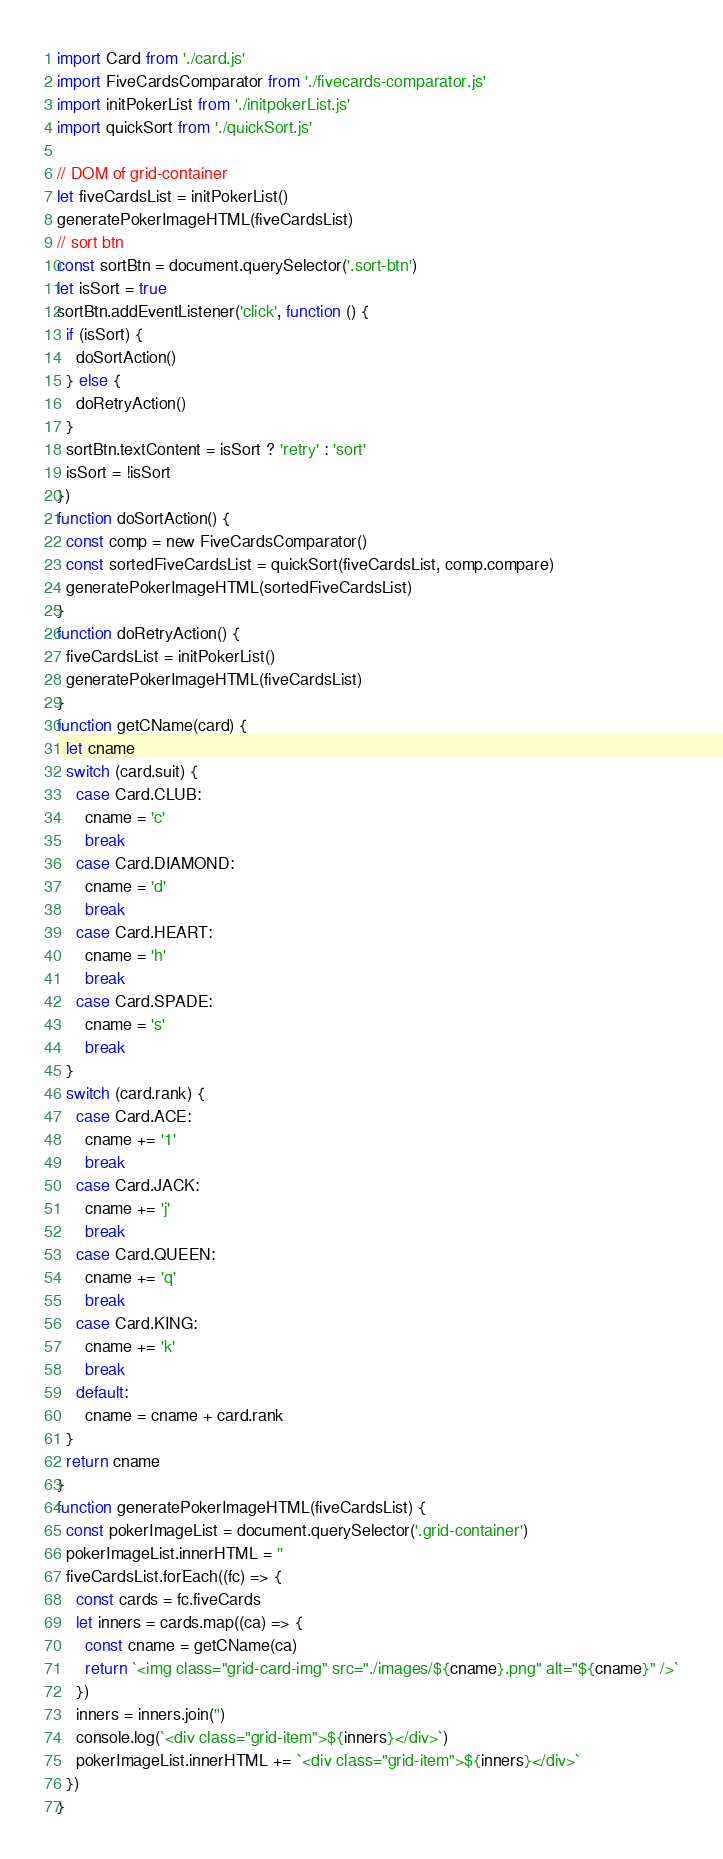Convert code to text. <code><loc_0><loc_0><loc_500><loc_500><_JavaScript_>import Card from './card.js'
import FiveCardsComparator from './fivecards-comparator.js'
import initPokerList from './initpokerList.js'
import quickSort from './quickSort.js'

// DOM of grid-container
let fiveCardsList = initPokerList()
generatePokerImageHTML(fiveCardsList)
// sort btn
const sortBtn = document.querySelector('.sort-btn')
let isSort = true
sortBtn.addEventListener('click', function () {
  if (isSort) {
    doSortAction()
  } else {
    doRetryAction()
  }
  sortBtn.textContent = isSort ? 'retry' : 'sort'
  isSort = !isSort
})
function doSortAction() {
  const comp = new FiveCardsComparator()
  const sortedFiveCardsList = quickSort(fiveCardsList, comp.compare)
  generatePokerImageHTML(sortedFiveCardsList)
}
function doRetryAction() {
  fiveCardsList = initPokerList()
  generatePokerImageHTML(fiveCardsList)
}
function getCName(card) {
  let cname
  switch (card.suit) {
    case Card.CLUB:
      cname = 'c'
      break
    case Card.DIAMOND:
      cname = 'd'
      break
    case Card.HEART:
      cname = 'h'
      break
    case Card.SPADE:
      cname = 's'
      break
  }
  switch (card.rank) {
    case Card.ACE:
      cname += '1'
      break
    case Card.JACK:
      cname += 'j'
      break
    case Card.QUEEN:
      cname += 'q'
      break
    case Card.KING:
      cname += 'k'
      break
    default:
      cname = cname + card.rank
  }
  return cname
}
function generatePokerImageHTML(fiveCardsList) {
  const pokerImageList = document.querySelector('.grid-container')
  pokerImageList.innerHTML = ''
  fiveCardsList.forEach((fc) => {
    const cards = fc.fiveCards
    let inners = cards.map((ca) => {
      const cname = getCName(ca)
      return `<img class="grid-card-img" src="./images/${cname}.png" alt="${cname}" />`
    })
    inners = inners.join('')
    console.log(`<div class="grid-item">${inners}</div>`)
    pokerImageList.innerHTML += `<div class="grid-item">${inners}</div>`
  })
}
</code> 